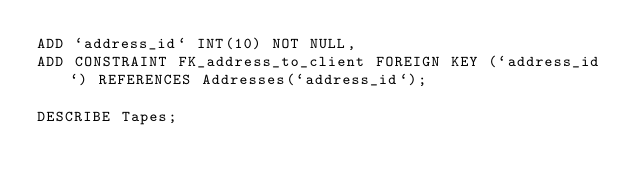<code> <loc_0><loc_0><loc_500><loc_500><_SQL_>ADD `address_id` INT(10) NOT NULL,
ADD CONSTRAINT FK_address_to_client FOREIGN KEY (`address_id`) REFERENCES Addresses(`address_id`);

DESCRIBE Tapes;</code> 